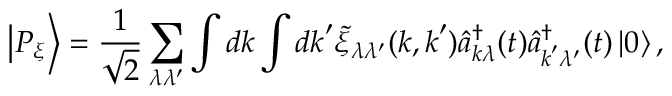<formula> <loc_0><loc_0><loc_500><loc_500>\left | P _ { \xi } \right \rangle = \frac { 1 } { \sqrt { 2 } } \sum _ { \lambda \lambda ^ { \prime } } \int d k \int d k ^ { \prime } \tilde { \xi } _ { \lambda \lambda ^ { \prime } } ( k , k ^ { \prime } ) \hat { a } _ { k \lambda } ^ { \dagger } ( t ) \hat { a } _ { k ^ { \prime } \lambda ^ { \prime } } ^ { \dagger } ( t ) \left | 0 \right \rangle ,</formula> 